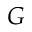<formula> <loc_0><loc_0><loc_500><loc_500>G</formula> 